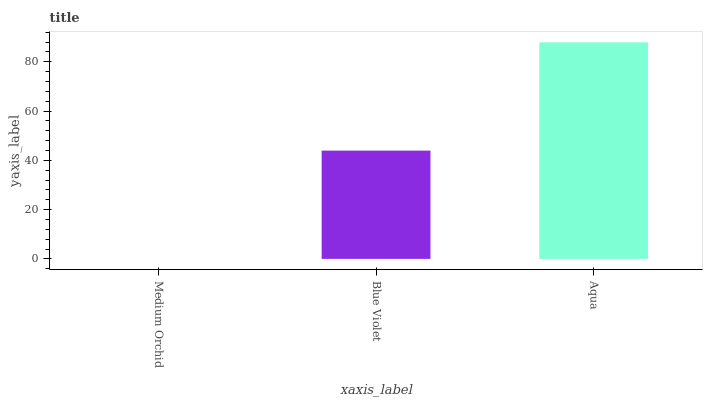Is Medium Orchid the minimum?
Answer yes or no. Yes. Is Aqua the maximum?
Answer yes or no. Yes. Is Blue Violet the minimum?
Answer yes or no. No. Is Blue Violet the maximum?
Answer yes or no. No. Is Blue Violet greater than Medium Orchid?
Answer yes or no. Yes. Is Medium Orchid less than Blue Violet?
Answer yes or no. Yes. Is Medium Orchid greater than Blue Violet?
Answer yes or no. No. Is Blue Violet less than Medium Orchid?
Answer yes or no. No. Is Blue Violet the high median?
Answer yes or no. Yes. Is Blue Violet the low median?
Answer yes or no. Yes. Is Medium Orchid the high median?
Answer yes or no. No. Is Medium Orchid the low median?
Answer yes or no. No. 